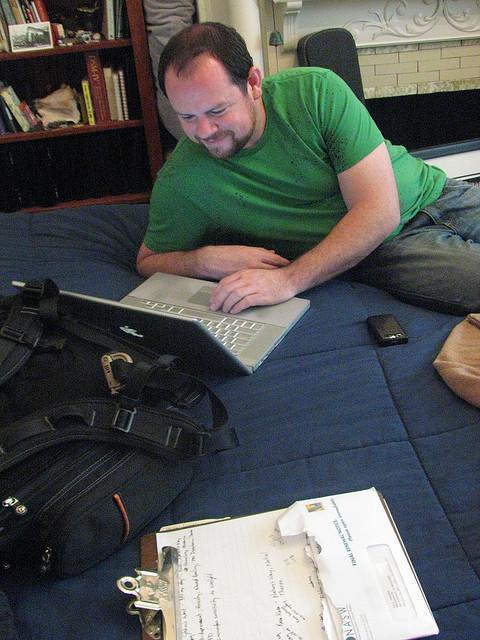How many backpacks can be seen?
Give a very brief answer. 1. How many yellow cars are there?
Give a very brief answer. 0. 